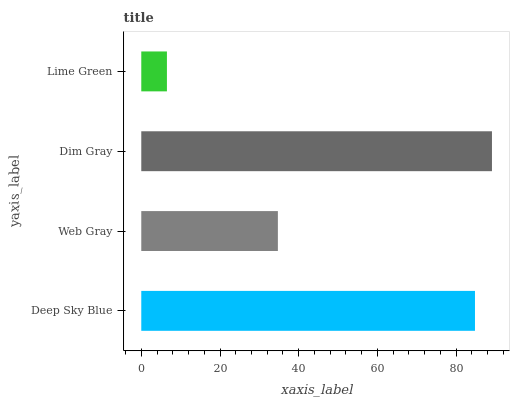Is Lime Green the minimum?
Answer yes or no. Yes. Is Dim Gray the maximum?
Answer yes or no. Yes. Is Web Gray the minimum?
Answer yes or no. No. Is Web Gray the maximum?
Answer yes or no. No. Is Deep Sky Blue greater than Web Gray?
Answer yes or no. Yes. Is Web Gray less than Deep Sky Blue?
Answer yes or no. Yes. Is Web Gray greater than Deep Sky Blue?
Answer yes or no. No. Is Deep Sky Blue less than Web Gray?
Answer yes or no. No. Is Deep Sky Blue the high median?
Answer yes or no. Yes. Is Web Gray the low median?
Answer yes or no. Yes. Is Dim Gray the high median?
Answer yes or no. No. Is Deep Sky Blue the low median?
Answer yes or no. No. 